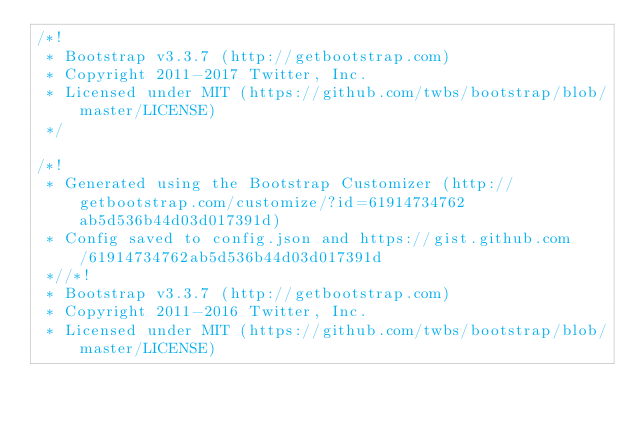<code> <loc_0><loc_0><loc_500><loc_500><_CSS_>/*!
 * Bootstrap v3.3.7 (http://getbootstrap.com)
 * Copyright 2011-2017 Twitter, Inc.
 * Licensed under MIT (https://github.com/twbs/bootstrap/blob/master/LICENSE)
 */

/*!
 * Generated using the Bootstrap Customizer (http://getbootstrap.com/customize/?id=61914734762ab5d536b44d03d017391d)
 * Config saved to config.json and https://gist.github.com/61914734762ab5d536b44d03d017391d
 *//*!
 * Bootstrap v3.3.7 (http://getbootstrap.com)
 * Copyright 2011-2016 Twitter, Inc.
 * Licensed under MIT (https://github.com/twbs/bootstrap/blob/master/LICENSE)</code> 